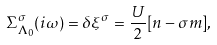Convert formula to latex. <formula><loc_0><loc_0><loc_500><loc_500>\Sigma _ { \Lambda _ { 0 } } ^ { \sigma } ( i \omega ) = \delta \xi ^ { \sigma } = \frac { U } { 2 } [ { n } - \sigma { m } ] ,</formula> 